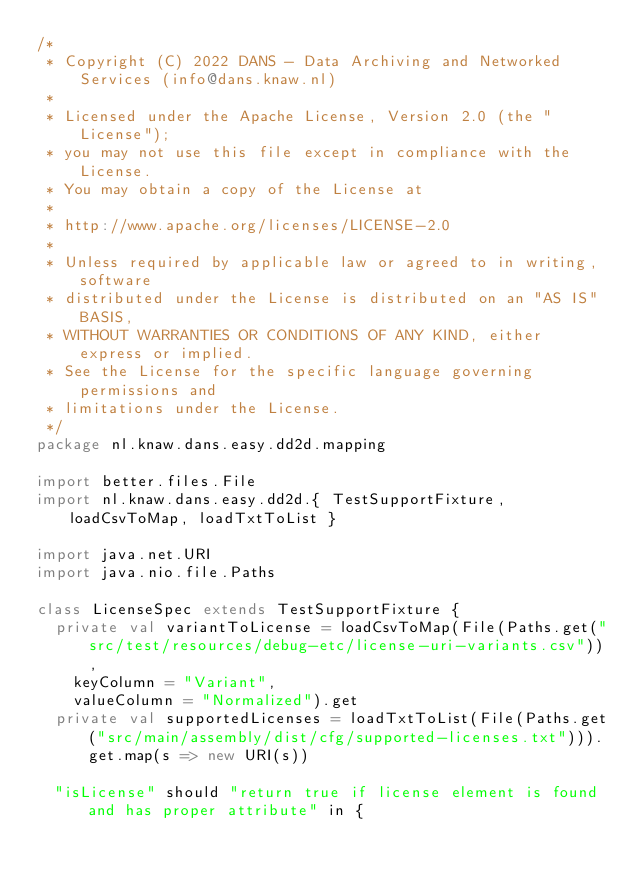<code> <loc_0><loc_0><loc_500><loc_500><_Scala_>/*
 * Copyright (C) 2022 DANS - Data Archiving and Networked Services (info@dans.knaw.nl)
 *
 * Licensed under the Apache License, Version 2.0 (the "License");
 * you may not use this file except in compliance with the License.
 * You may obtain a copy of the License at
 *
 * http://www.apache.org/licenses/LICENSE-2.0
 *
 * Unless required by applicable law or agreed to in writing, software
 * distributed under the License is distributed on an "AS IS" BASIS,
 * WITHOUT WARRANTIES OR CONDITIONS OF ANY KIND, either express or implied.
 * See the License for the specific language governing permissions and
 * limitations under the License.
 */
package nl.knaw.dans.easy.dd2d.mapping

import better.files.File
import nl.knaw.dans.easy.dd2d.{ TestSupportFixture, loadCsvToMap, loadTxtToList }

import java.net.URI
import java.nio.file.Paths

class LicenseSpec extends TestSupportFixture {
  private val variantToLicense = loadCsvToMap(File(Paths.get("src/test/resources/debug-etc/license-uri-variants.csv")),
    keyColumn = "Variant",
    valueColumn = "Normalized").get
  private val supportedLicenses = loadTxtToList(File(Paths.get("src/main/assembly/dist/cfg/supported-licenses.txt"))).get.map(s => new URI(s))

  "isLicense" should "return true if license element is found and has proper attribute" in {</code> 